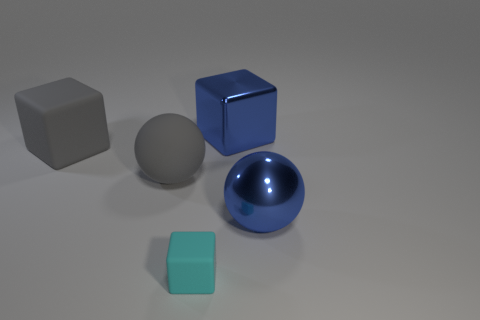Add 3 gray objects. How many objects exist? 8 Subtract all balls. How many objects are left? 3 Subtract all large green rubber cylinders. Subtract all large matte spheres. How many objects are left? 4 Add 3 big spheres. How many big spheres are left? 5 Add 3 gray rubber cubes. How many gray rubber cubes exist? 4 Subtract 1 gray spheres. How many objects are left? 4 